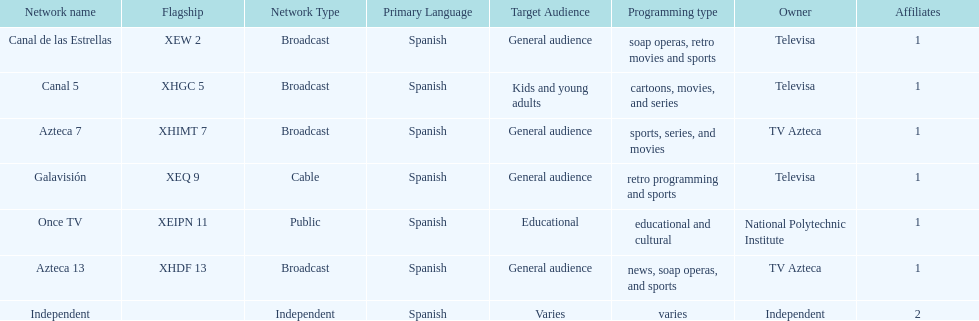What is the average number of affiliates that a given network will have? 1. 